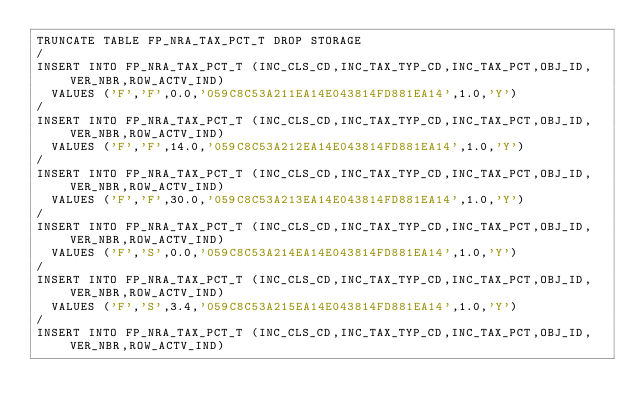<code> <loc_0><loc_0><loc_500><loc_500><_SQL_>TRUNCATE TABLE FP_NRA_TAX_PCT_T DROP STORAGE
/
INSERT INTO FP_NRA_TAX_PCT_T (INC_CLS_CD,INC_TAX_TYP_CD,INC_TAX_PCT,OBJ_ID,VER_NBR,ROW_ACTV_IND)
  VALUES ('F','F',0.0,'059C8C53A211EA14E043814FD881EA14',1.0,'Y')
/
INSERT INTO FP_NRA_TAX_PCT_T (INC_CLS_CD,INC_TAX_TYP_CD,INC_TAX_PCT,OBJ_ID,VER_NBR,ROW_ACTV_IND)
  VALUES ('F','F',14.0,'059C8C53A212EA14E043814FD881EA14',1.0,'Y')
/
INSERT INTO FP_NRA_TAX_PCT_T (INC_CLS_CD,INC_TAX_TYP_CD,INC_TAX_PCT,OBJ_ID,VER_NBR,ROW_ACTV_IND)
  VALUES ('F','F',30.0,'059C8C53A213EA14E043814FD881EA14',1.0,'Y')
/
INSERT INTO FP_NRA_TAX_PCT_T (INC_CLS_CD,INC_TAX_TYP_CD,INC_TAX_PCT,OBJ_ID,VER_NBR,ROW_ACTV_IND)
  VALUES ('F','S',0.0,'059C8C53A214EA14E043814FD881EA14',1.0,'Y')
/
INSERT INTO FP_NRA_TAX_PCT_T (INC_CLS_CD,INC_TAX_TYP_CD,INC_TAX_PCT,OBJ_ID,VER_NBR,ROW_ACTV_IND)
  VALUES ('F','S',3.4,'059C8C53A215EA14E043814FD881EA14',1.0,'Y')
/
INSERT INTO FP_NRA_TAX_PCT_T (INC_CLS_CD,INC_TAX_TYP_CD,INC_TAX_PCT,OBJ_ID,VER_NBR,ROW_ACTV_IND)</code> 